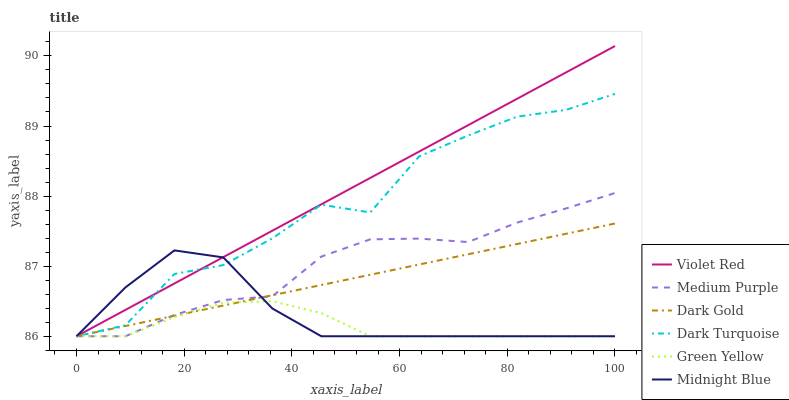Does Green Yellow have the minimum area under the curve?
Answer yes or no. Yes. Does Violet Red have the maximum area under the curve?
Answer yes or no. Yes. Does Midnight Blue have the minimum area under the curve?
Answer yes or no. No. Does Midnight Blue have the maximum area under the curve?
Answer yes or no. No. Is Dark Gold the smoothest?
Answer yes or no. Yes. Is Dark Turquoise the roughest?
Answer yes or no. Yes. Is Midnight Blue the smoothest?
Answer yes or no. No. Is Midnight Blue the roughest?
Answer yes or no. No. Does Violet Red have the lowest value?
Answer yes or no. Yes. Does Violet Red have the highest value?
Answer yes or no. Yes. Does Midnight Blue have the highest value?
Answer yes or no. No. Does Midnight Blue intersect Dark Turquoise?
Answer yes or no. Yes. Is Midnight Blue less than Dark Turquoise?
Answer yes or no. No. Is Midnight Blue greater than Dark Turquoise?
Answer yes or no. No. 